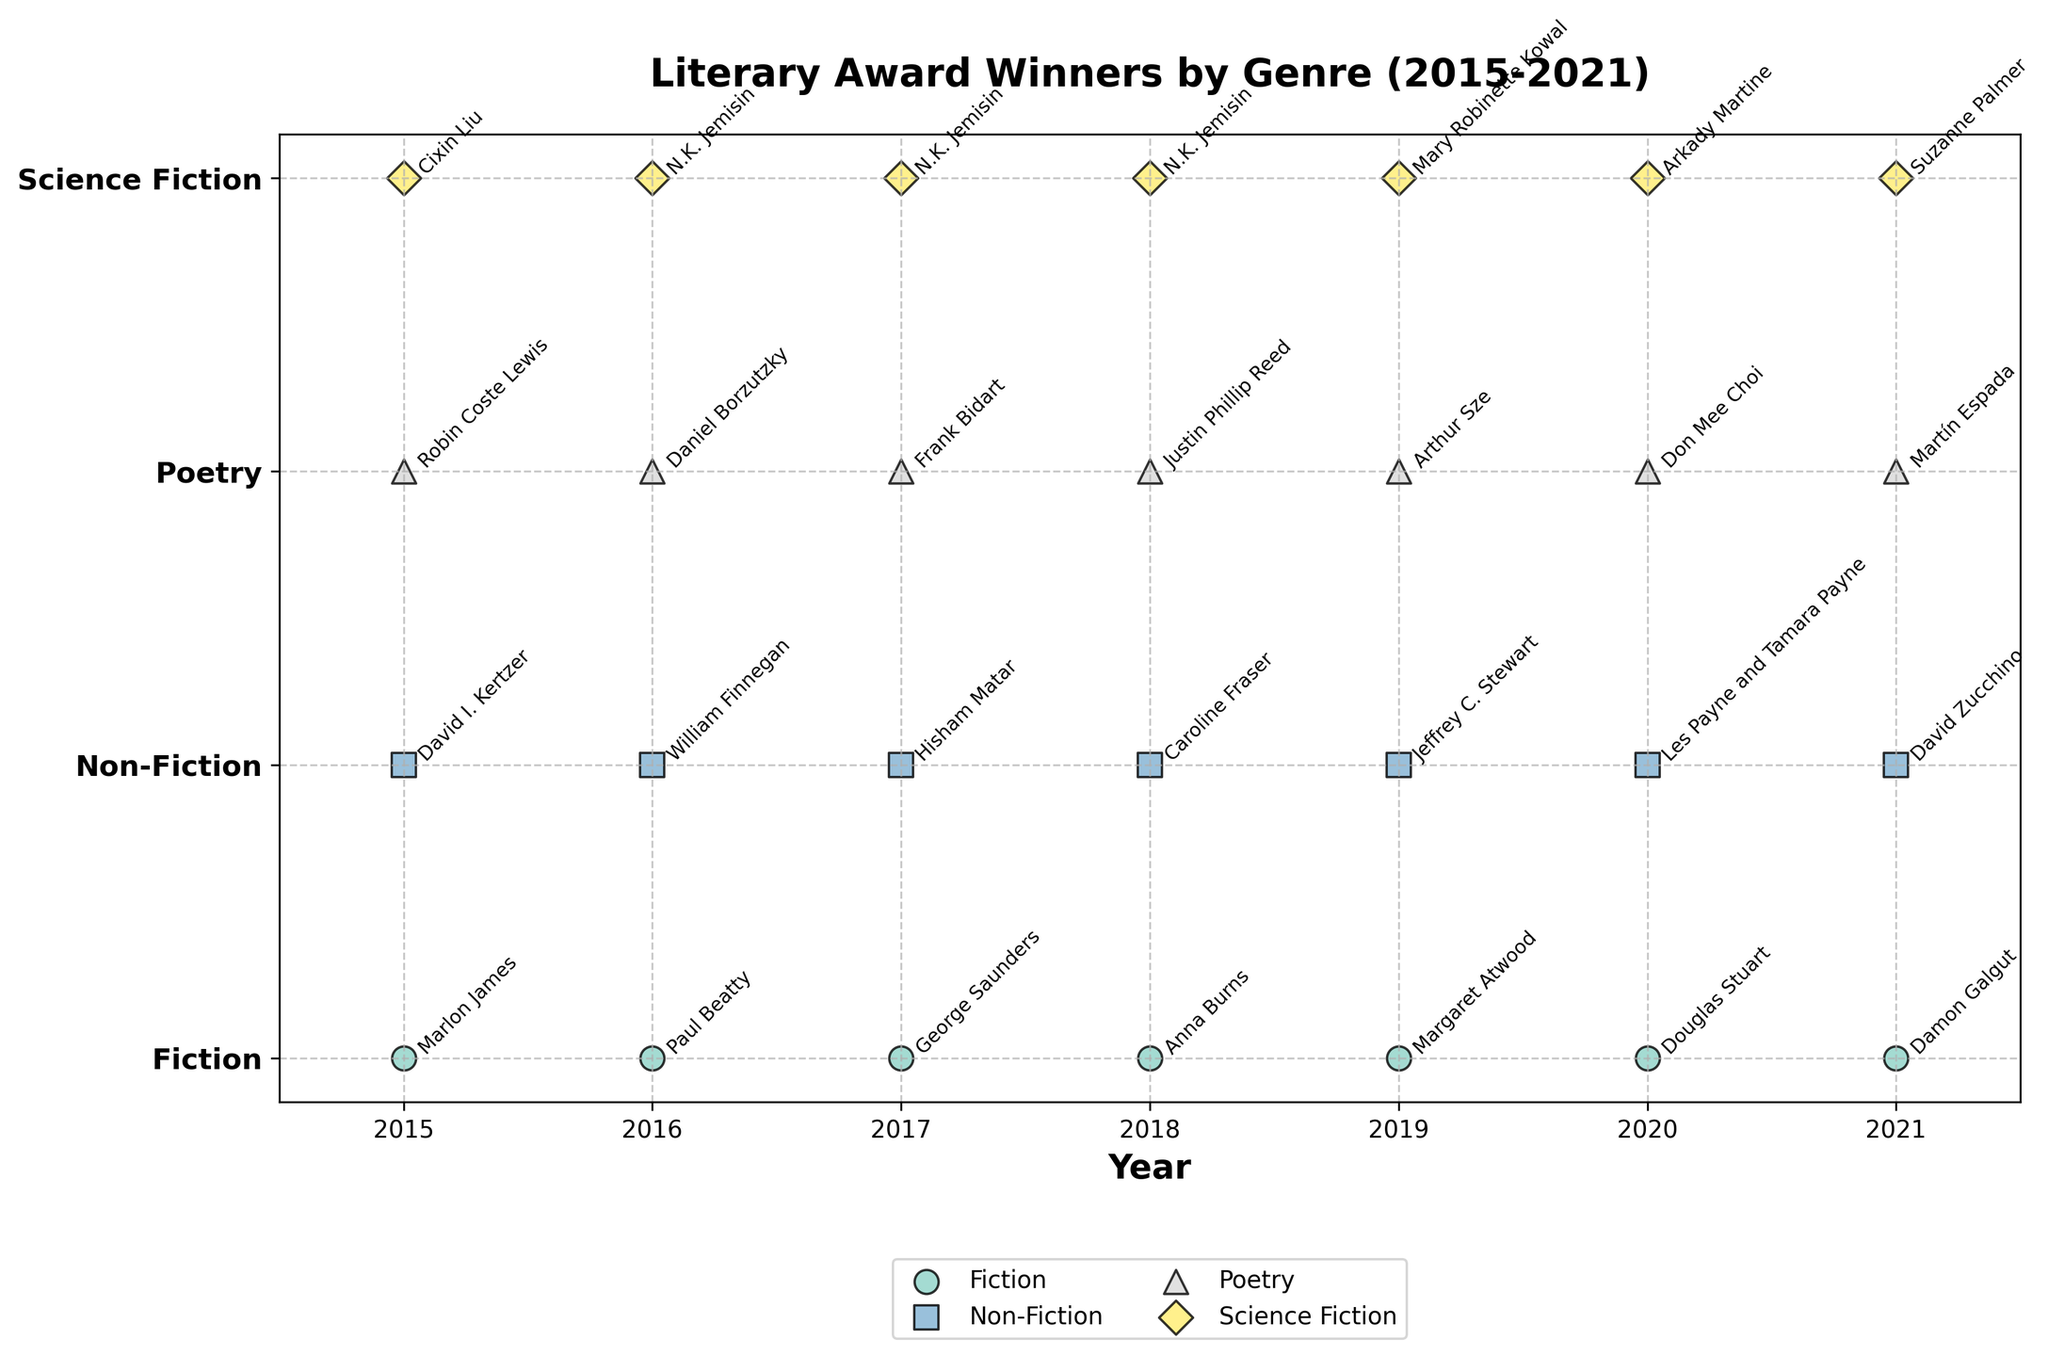what is the title of the plot? The title of the plot is presented prominently at the top of the figure and reads "Literary Award Winners by Genre (2015-2021)."
Answer: Literary Award Winners by Genre (2015-2021) How many genres are represented in the plot? The y-axis of the plot lists the genres, and counting the unique genres will give the total number. The plot shows the genres as Fiction, Non-Fiction, Poetry, and Science Fiction.
Answer: 4 Which genre has the most consistent winner? By examining the data points and the annotations for the winners in each genre, Science Fiction clearly has the same winner, N.K. Jemisin, for three consecutive years (2016, 2017, 2018).
Answer: Science Fiction How many literary awards are displayed for the year 2019? By identifying the year 2019 on the x-axis and counting the data points aligned vertically at this year, we see four awards: one for each genre.
Answer: 4 What is the range of years displayed on the x-axis? The x-axis has labels indicating the start and end years. The plot starts at 2015 and ends at 2021.
Answer: 2015-2021 Who won the most recent Pulitzer Prize for Biography? Looking at the data points in the row labeled Non-Fiction for the year 2021, the annotation shows David Zucchino as the winner.
Answer: David Zucchino Which genre has the greatest number of unique winners across all years? By examining each genre and counting distinct names for each category: Fiction (7), Non-Fiction (7), Poetry (7), and Science Fiction (5). Each of Fiction, Non-Fiction, and Poetry has 7 unique winners, the highest number.
Answer: Fiction, Non-Fiction, Poetry Which genre has the least variation in winners? From the plot, Science Fiction has the least variation in winners, with a notable repeat in consecutive years by the same author (N.K. Jemisin).
Answer: Science Fiction How many times did Margaret Atwood win the Man Booker Prize during the period shown? By focusing on Fiction and checking the winner names yearly from 2015 to 2021 in that row, Margaret Atwood appears only once in 2019.
Answer: 1 